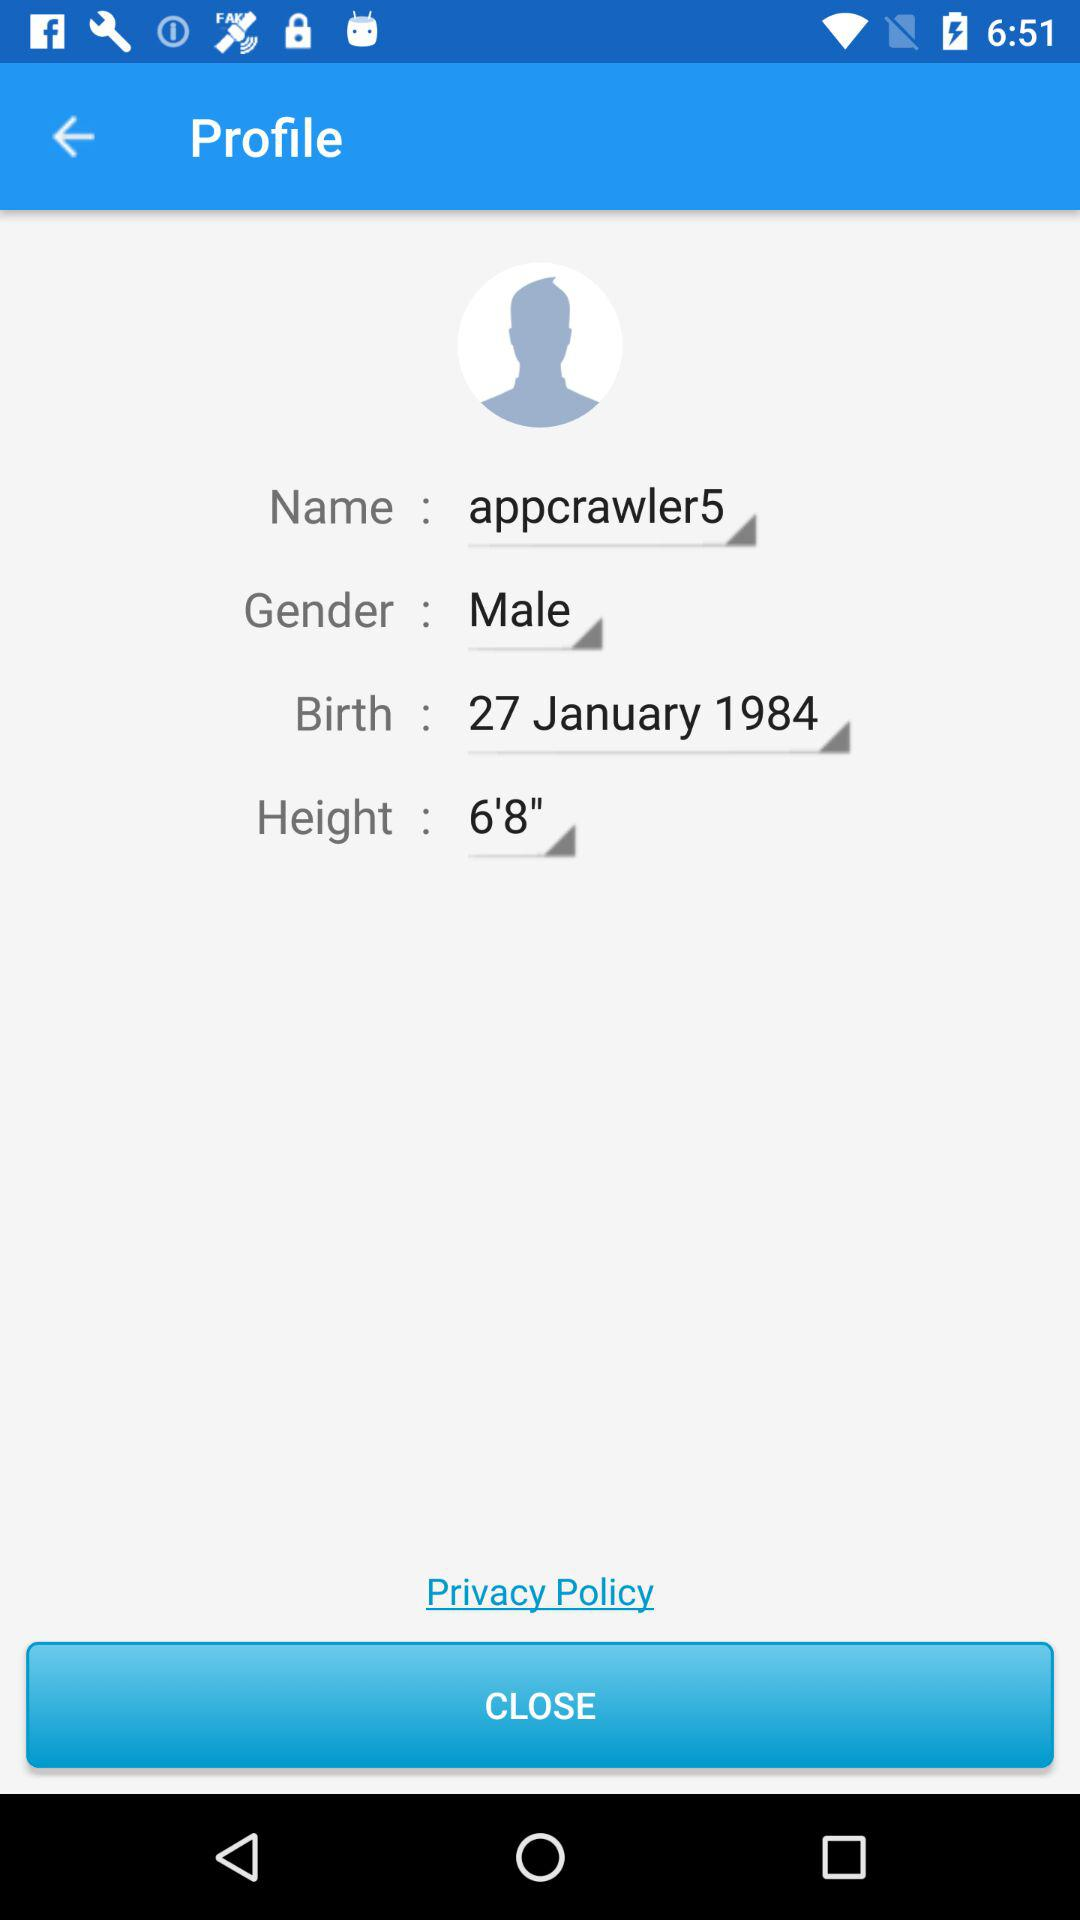What is the gender? The gender is male. 